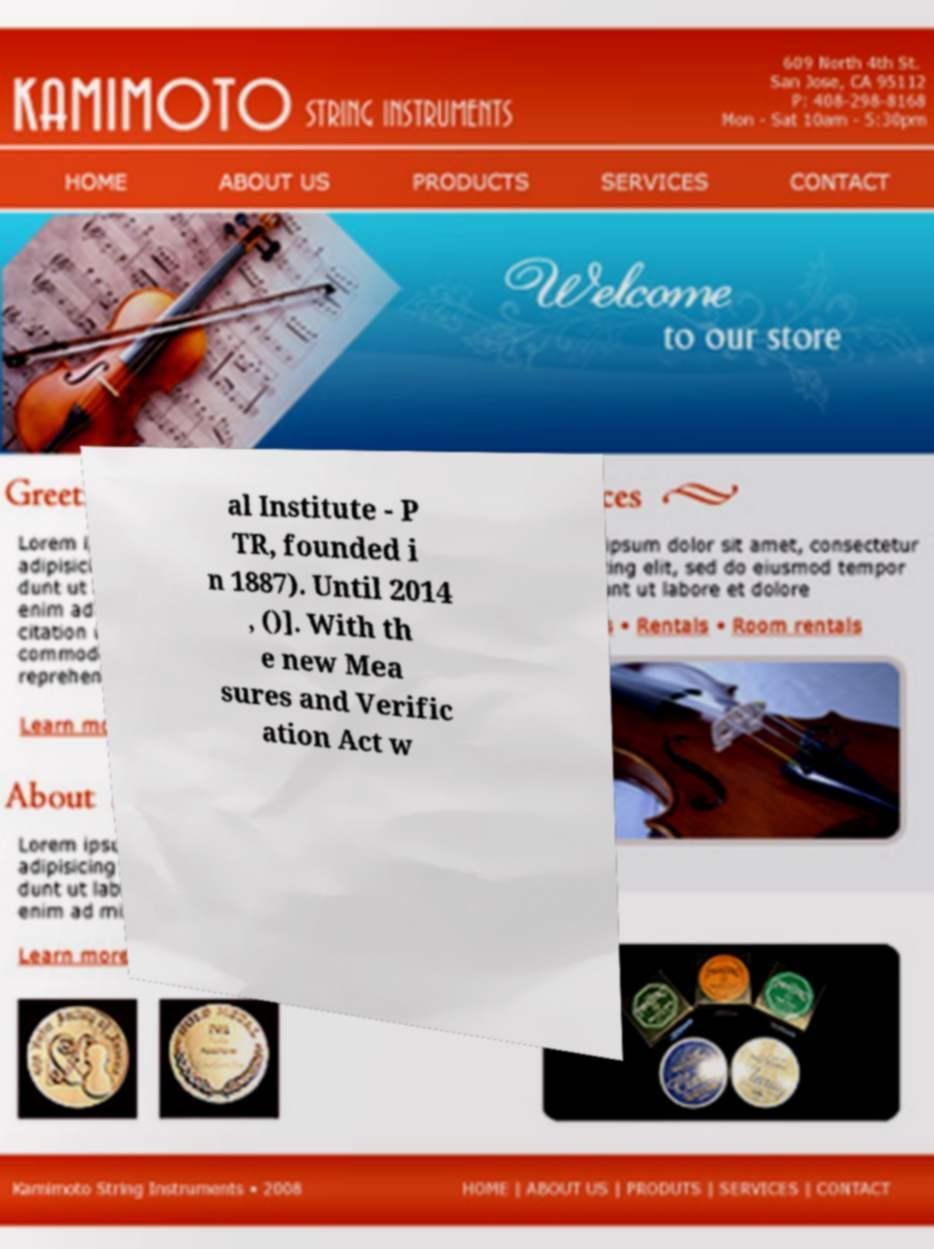Can you read and provide the text displayed in the image?This photo seems to have some interesting text. Can you extract and type it out for me? al Institute - P TR, founded i n 1887). Until 2014 , ()]. With th e new Mea sures and Verific ation Act w 